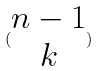<formula> <loc_0><loc_0><loc_500><loc_500>( \begin{matrix} n - 1 \\ k \end{matrix} )</formula> 